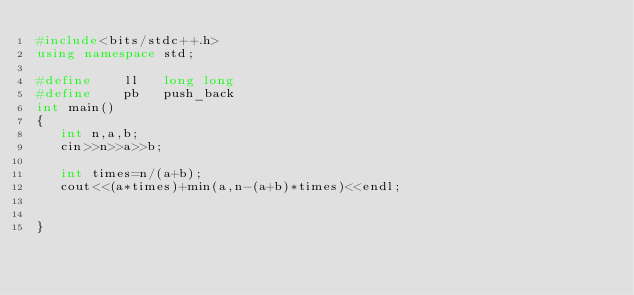<code> <loc_0><loc_0><loc_500><loc_500><_C++_>#include<bits/stdc++.h>
using namespace std;

#define    ll   long long 
#define    pb   push_back
int main()
{
   int n,a,b;
   cin>>n>>a>>b;
   
   int times=n/(a+b);
   cout<<(a*times)+min(a,n-(a+b)*times)<<endl;
	
 
}</code> 